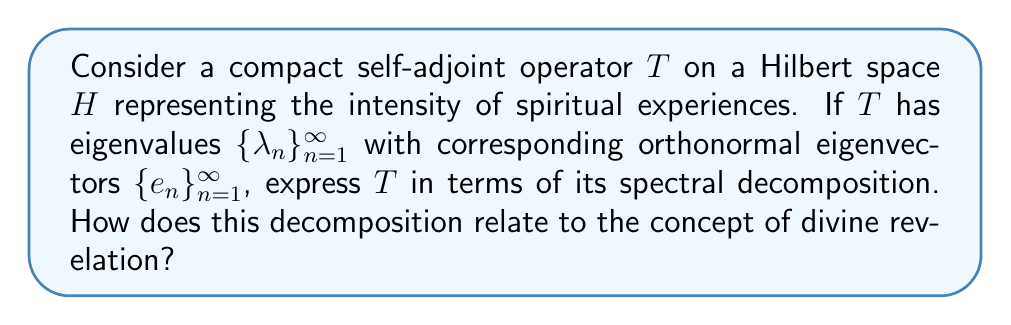Give your solution to this math problem. Let's approach this step-by-step:

1) For a compact self-adjoint operator $T$ on a Hilbert space $H$, the spectral theorem states that $T$ can be expressed as:

   $$T = \sum_{n=1}^{\infty} \lambda_n P_n$$

   where $P_n$ is the orthogonal projection onto the eigenspace corresponding to $\lambda_n$.

2) In this case, since we have orthonormal eigenvectors $\{e_n\}_{n=1}^{\infty}$, each $P_n$ can be expressed as:

   $$P_n = e_n \otimes e_n$$

   where $\otimes$ denotes the outer product.

3) Substituting this into our spectral decomposition:

   $$T = \sum_{n=1}^{\infty} \lambda_n (e_n \otimes e_n)$$

4) For any $x \in H$, the action of $T$ on $x$ can be written as:

   $$Tx = \sum_{n=1}^{\infty} \lambda_n \langle x, e_n \rangle e_n$$

5) This decomposition allows us to express $T$ as a sum of simpler rank-one operators, each corresponding to an eigenvalue and its associated eigenvector.

6) From a theological perspective, this decomposition could be interpreted as follows:
   - The eigenvalues $\lambda_n$ represent the intensity or significance of different aspects of spiritual experiences.
   - The eigenvectors $e_n$ represent distinct types or qualities of spiritual experiences.
   - The decomposition suggests that complex spiritual experiences (represented by $T$) can be understood as a combination of more fundamental spiritual elements, each with its own significance.

7) The concept of divine revelation could be related to this decomposition in that it suggests a structured, multi-faceted nature to spiritual experiences, potentially reflecting different aspects of divine communication or presence.
Answer: $T = \sum_{n=1}^{\infty} \lambda_n (e_n \otimes e_n)$ 